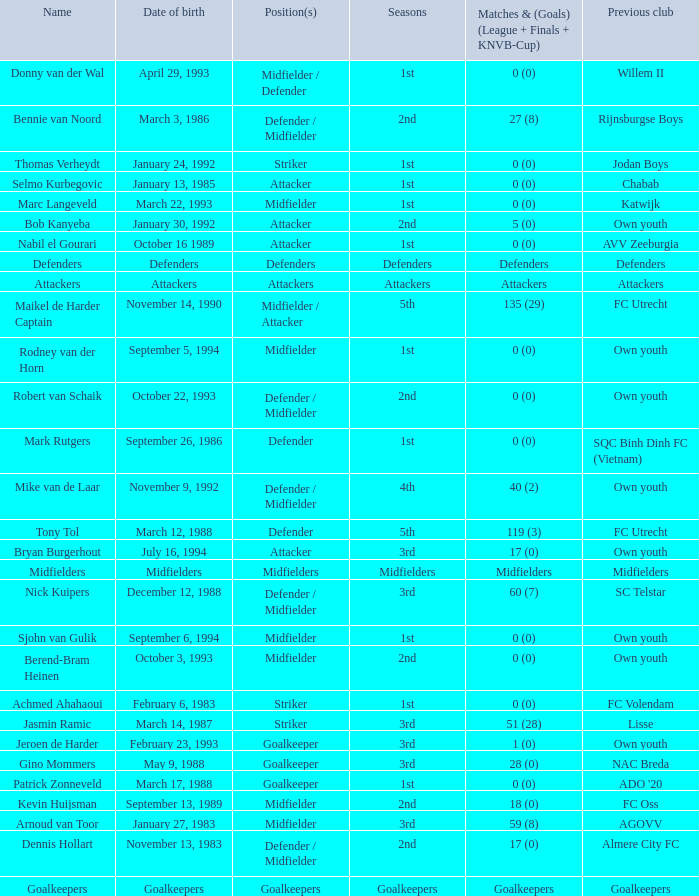What previous club was born on October 22, 1993? Own youth. 